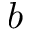<formula> <loc_0><loc_0><loc_500><loc_500>b</formula> 